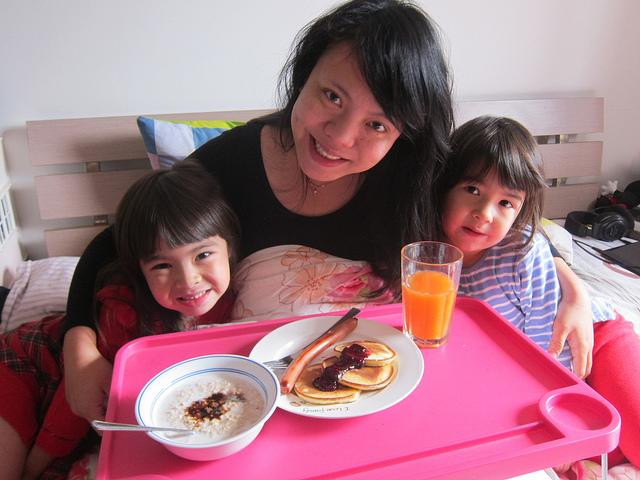How do these people know each other? family 